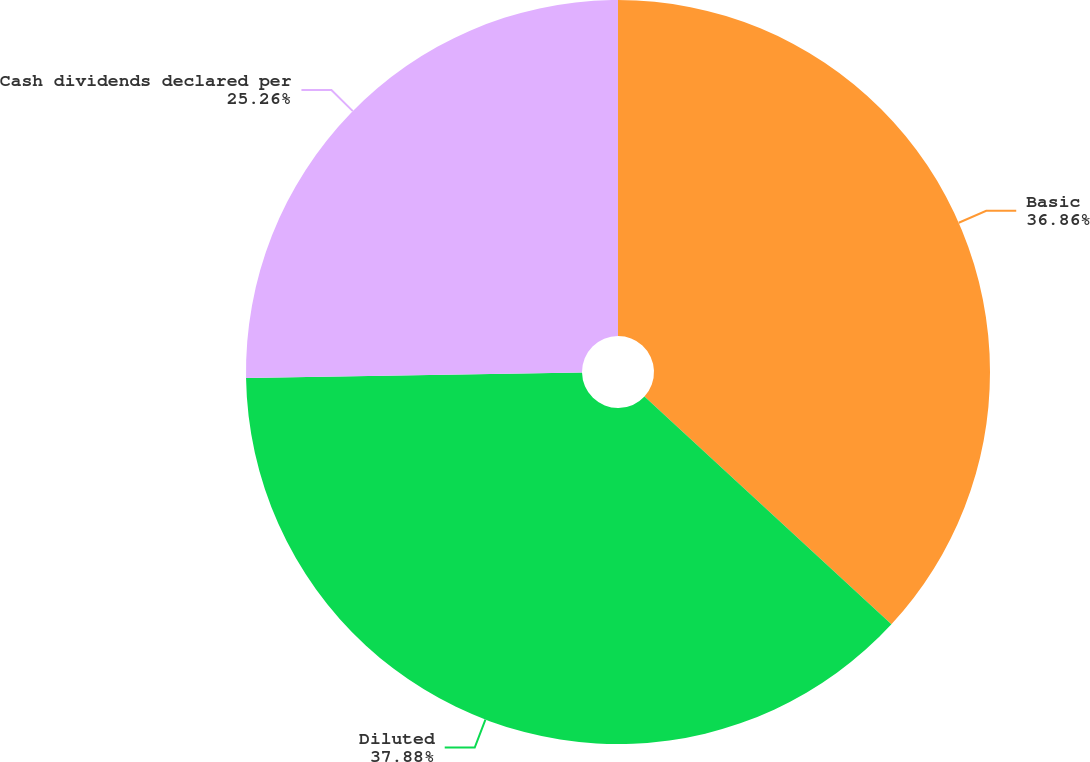Convert chart. <chart><loc_0><loc_0><loc_500><loc_500><pie_chart><fcel>Basic<fcel>Diluted<fcel>Cash dividends declared per<nl><fcel>36.86%<fcel>37.88%<fcel>25.26%<nl></chart> 